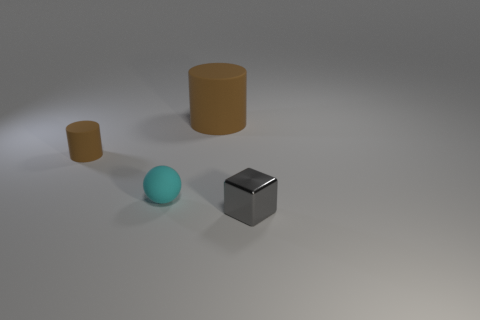Is there any other thing that is the same shape as the metal object?
Provide a succinct answer. No. There is a small thing that is on the right side of the cylinder to the right of the cylinder that is on the left side of the large brown object; what is its material?
Your response must be concise. Metal. The big brown object that is made of the same material as the tiny brown object is what shape?
Your response must be concise. Cylinder. Is there any other thing that has the same color as the large matte cylinder?
Your answer should be compact. Yes. How many big cylinders are in front of the matte object behind the thing left of the cyan thing?
Your answer should be compact. 0. How many blue things are either small cylinders or tiny metal objects?
Keep it short and to the point. 0. There is a gray thing; is its size the same as the brown cylinder that is in front of the big brown rubber cylinder?
Ensure brevity in your answer.  Yes. What is the material of the large thing that is the same shape as the tiny brown object?
Keep it short and to the point. Rubber. How many other things are there of the same size as the gray shiny cube?
Keep it short and to the point. 2. There is a tiny matte thing that is behind the cyan matte sphere in front of the brown thing that is to the left of the tiny cyan sphere; what is its shape?
Give a very brief answer. Cylinder. 